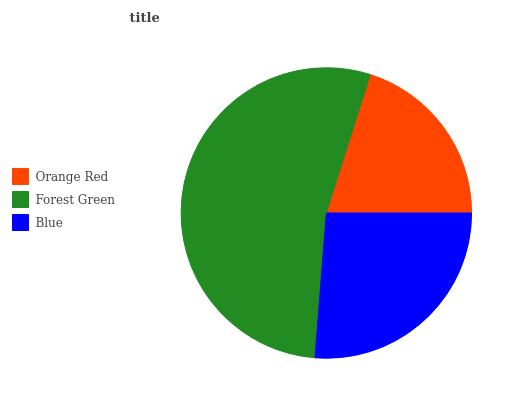Is Orange Red the minimum?
Answer yes or no. Yes. Is Forest Green the maximum?
Answer yes or no. Yes. Is Blue the minimum?
Answer yes or no. No. Is Blue the maximum?
Answer yes or no. No. Is Forest Green greater than Blue?
Answer yes or no. Yes. Is Blue less than Forest Green?
Answer yes or no. Yes. Is Blue greater than Forest Green?
Answer yes or no. No. Is Forest Green less than Blue?
Answer yes or no. No. Is Blue the high median?
Answer yes or no. Yes. Is Blue the low median?
Answer yes or no. Yes. Is Forest Green the high median?
Answer yes or no. No. Is Forest Green the low median?
Answer yes or no. No. 